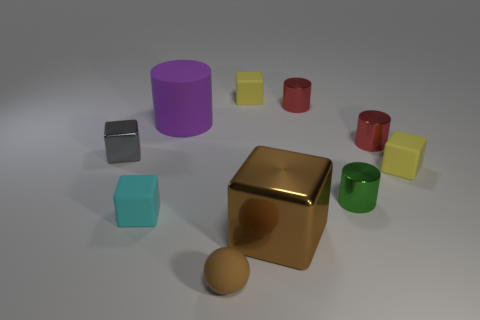Subtract all cyan blocks. How many blocks are left? 4 Subtract all brown shiny blocks. How many blocks are left? 4 Subtract all purple cubes. Subtract all cyan spheres. How many cubes are left? 5 Subtract all spheres. How many objects are left? 9 Subtract all purple objects. Subtract all small red metal things. How many objects are left? 7 Add 7 gray blocks. How many gray blocks are left? 8 Add 4 large matte cylinders. How many large matte cylinders exist? 5 Subtract 0 gray cylinders. How many objects are left? 10 